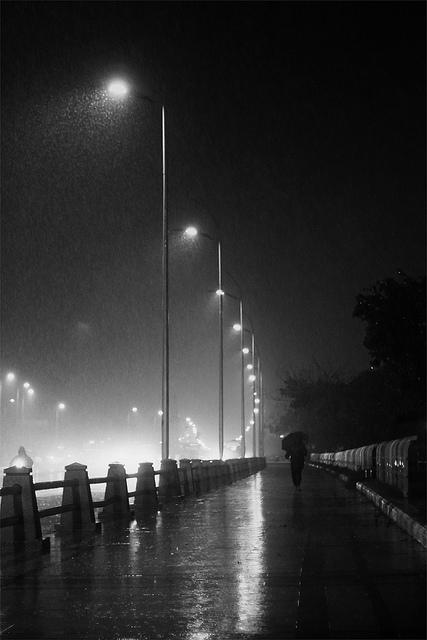Is it foggy out?
Write a very short answer. Yes. How is the weather being depicted in the picture?
Write a very short answer. Rainy. Is there anyone outside?
Give a very brief answer. Yes. 